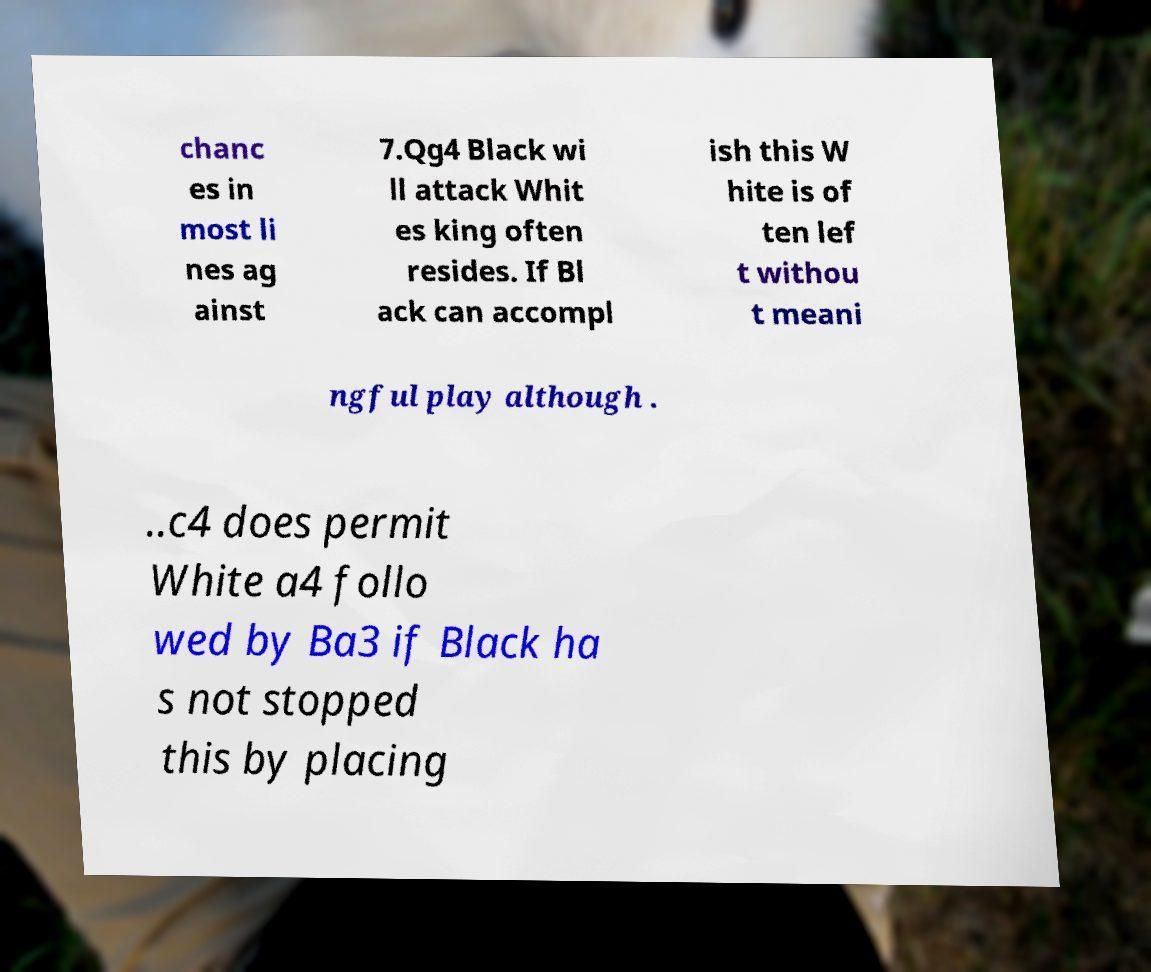What messages or text are displayed in this image? I need them in a readable, typed format. chanc es in most li nes ag ainst 7.Qg4 Black wi ll attack Whit es king often resides. If Bl ack can accompl ish this W hite is of ten lef t withou t meani ngful play although . ..c4 does permit White a4 follo wed by Ba3 if Black ha s not stopped this by placing 